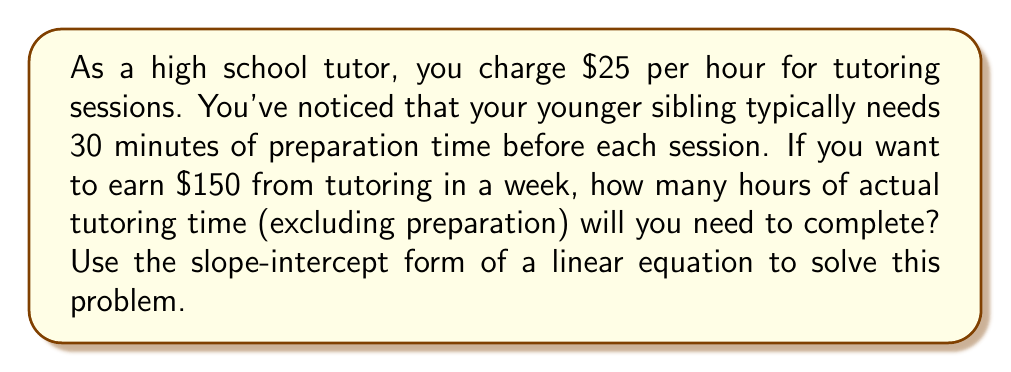Show me your answer to this math problem. Let's approach this step-by-step using the slope-intercept form of a linear equation:

1) The slope-intercept form is $y = mx + b$, where:
   $y$ is the total earnings
   $m$ is the hourly rate
   $x$ is the number of tutoring hours
   $b$ is the y-intercept (in this case, it will be negative due to unpaid preparation time)

2) We know:
   - Hourly rate: $25/hour
   - Preparation time: 0.5 hours per session
   - Target earnings: $150

3) Let's set up our equation:
   $y = 25x - 12.5$
   
   The -12.5 comes from: $25 * 0.5 = 12.5$ (the cost of 30 minutes of unpaid prep time)

4) Now, we want to find $x$ when $y = 150$:

   $150 = 25x - 12.5$

5) Solve for $x$:
   $150 + 12.5 = 25x$
   $162.5 = 25x$
   $x = 162.5 / 25 = 6.5$

Therefore, you need 6.5 hours of actual tutoring time to earn $150.
Answer: 6.5 hours of tutoring time 